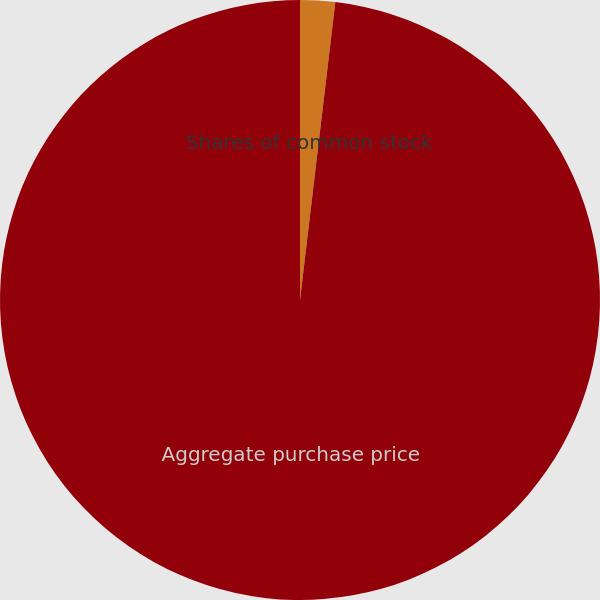<chart> <loc_0><loc_0><loc_500><loc_500><pie_chart><fcel>Shares of common stock<fcel>Aggregate purchase price<nl><fcel>1.88%<fcel>98.12%<nl></chart> 